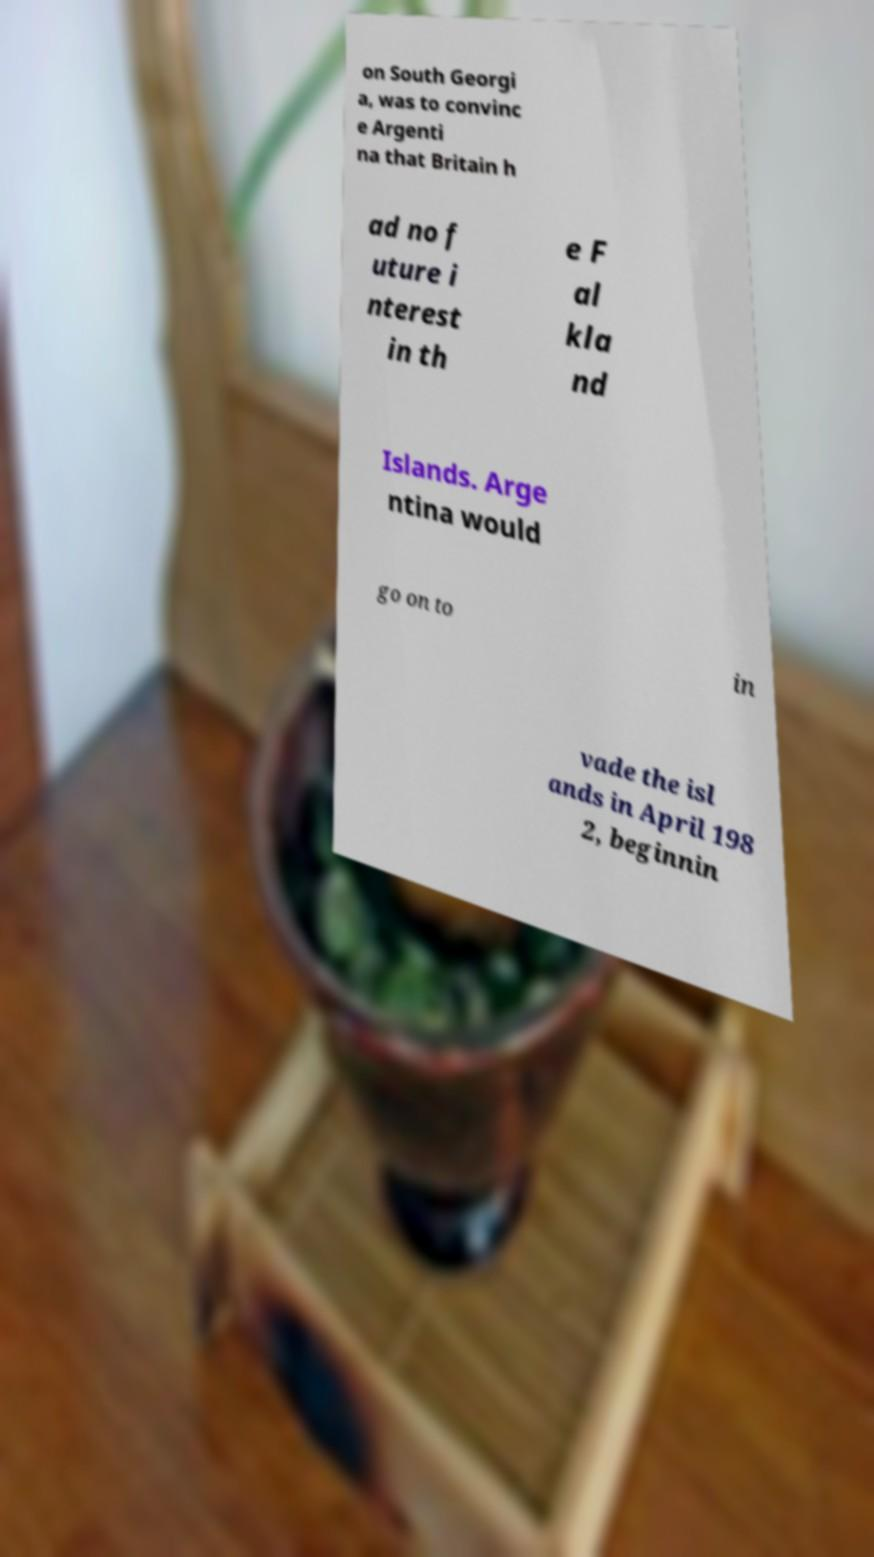Can you accurately transcribe the text from the provided image for me? on South Georgi a, was to convinc e Argenti na that Britain h ad no f uture i nterest in th e F al kla nd Islands. Arge ntina would go on to in vade the isl ands in April 198 2, beginnin 